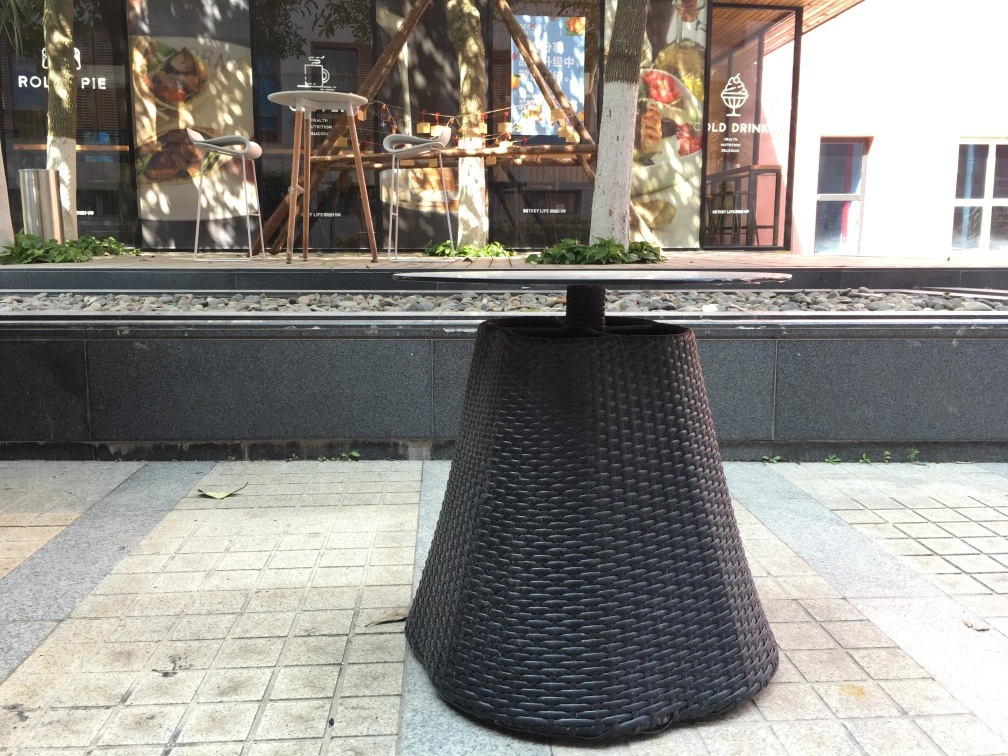What kind of setting does this image portray? The image portrays an urban-outdoor setting, possibly a sidewalk café or a leisure area, symbolized by the presence of a round wicker table, high stools, and decorative elements like the planted greenery and the neatly organized stones along the railway track motif. How does the image make you feel? The image invokes a sense of relaxation and tranquility, possibly due to the empty chairs that invite passersby to take a moment's rest and the relative calmness and orderliness of the setup. 